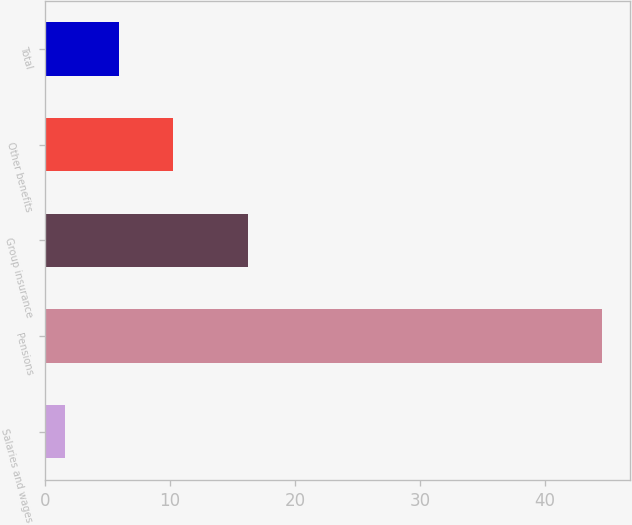Convert chart to OTSL. <chart><loc_0><loc_0><loc_500><loc_500><bar_chart><fcel>Salaries and wages<fcel>Pensions<fcel>Group insurance<fcel>Other benefits<fcel>Total<nl><fcel>1.6<fcel>44.6<fcel>16.2<fcel>10.2<fcel>5.9<nl></chart> 